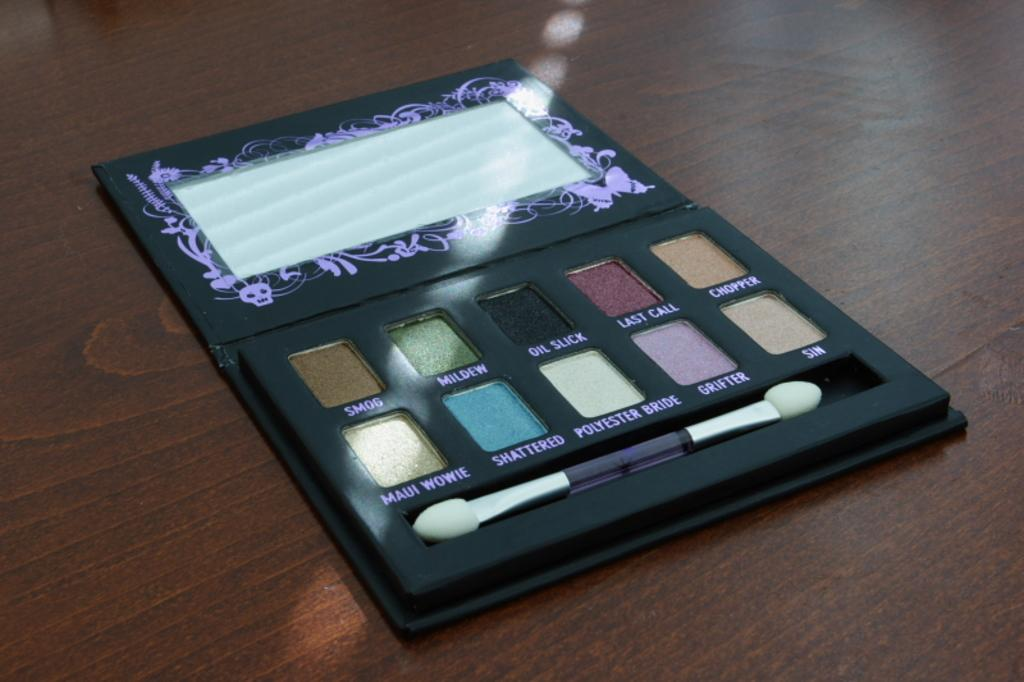Where was the image taken? The image was taken indoors. What can be seen on the table in the image? There is an eyeshadow palette on the table. Can you describe the setting of the image? The image shows a table with an eyeshadow palette, suggesting it might be in a makeup or dressing area. What is the income of the fly buzzing around the eyeshadow palette in the image? There is no fly present in the image, so it is not possible to determine its income. 